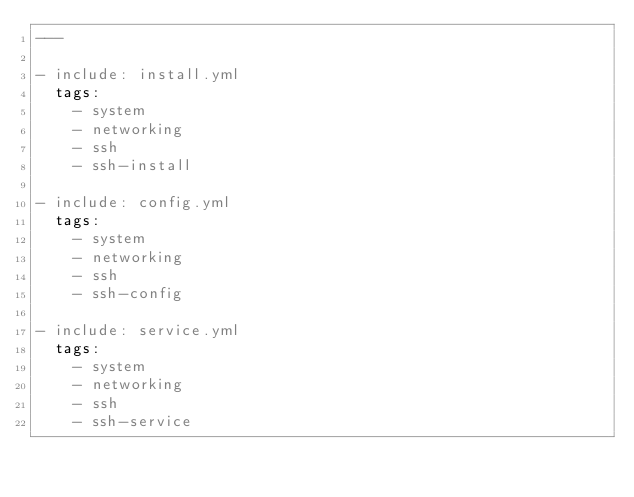<code> <loc_0><loc_0><loc_500><loc_500><_YAML_>---

- include: install.yml
  tags:
    - system
    - networking
    - ssh
    - ssh-install

- include: config.yml
  tags:
    - system
    - networking
    - ssh
    - ssh-config

- include: service.yml
  tags:
    - system
    - networking
    - ssh
    - ssh-service
</code> 